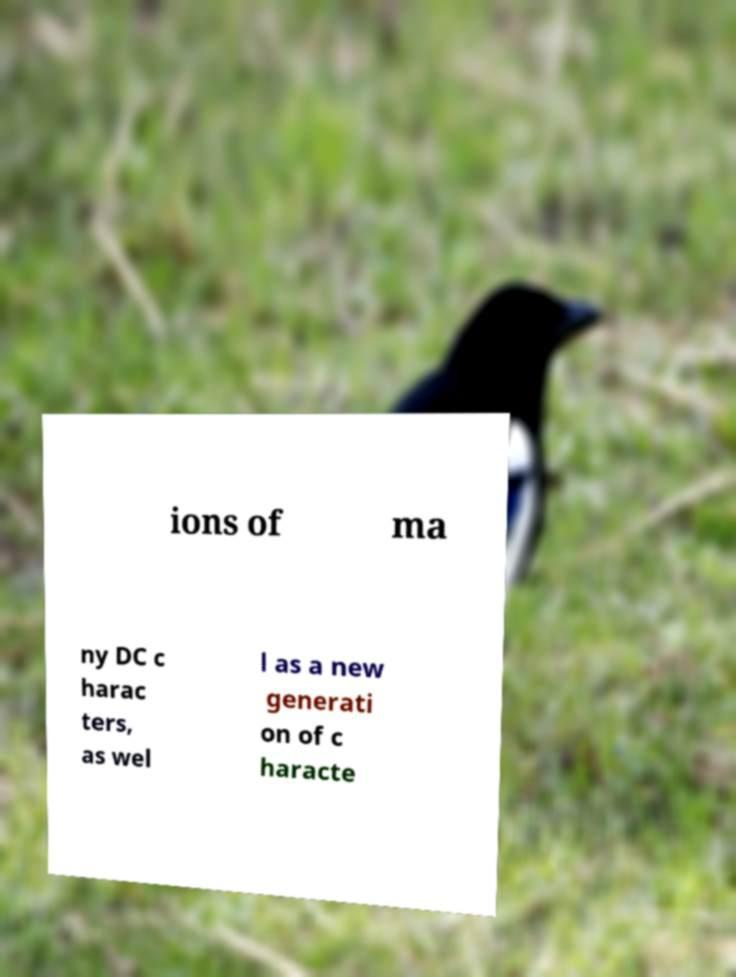Please identify and transcribe the text found in this image. ions of ma ny DC c harac ters, as wel l as a new generati on of c haracte 